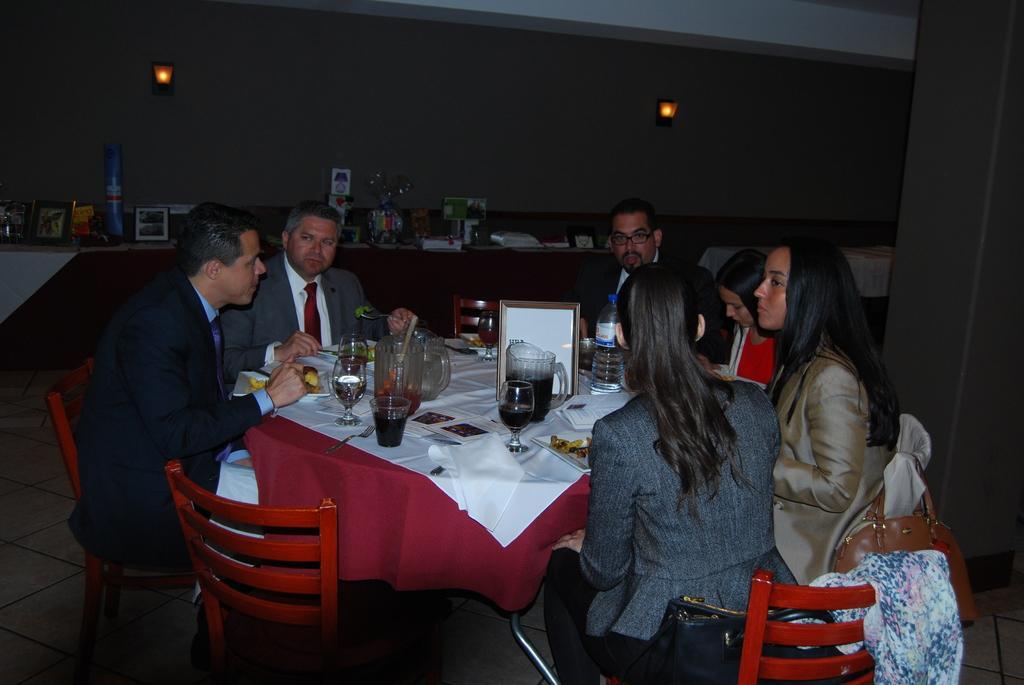In one or two sentences, can you explain what this image depicts? In this image we can see a group of people sitting in front of a table on chairs and in front of them there is soft drinks present in glasses, there is a bottle of water present 